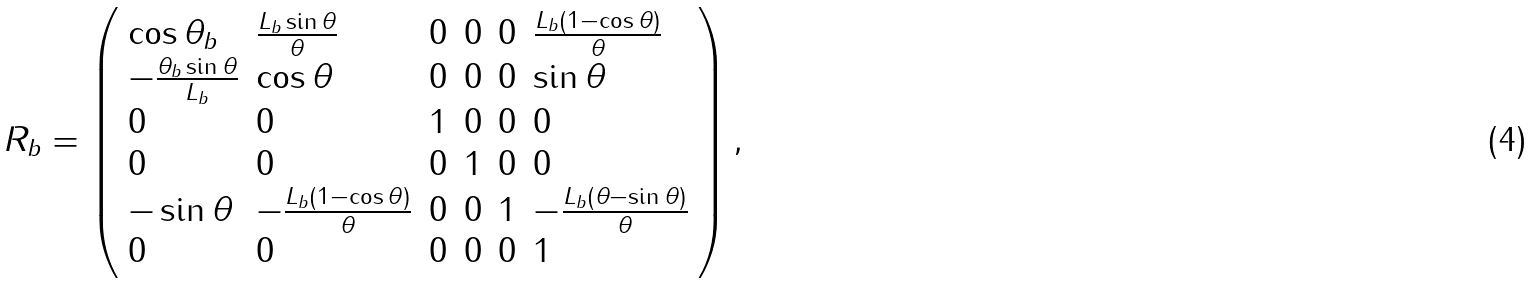Convert formula to latex. <formula><loc_0><loc_0><loc_500><loc_500>R _ { b } = \left ( \begin{array} { l l l l l l } \cos \theta _ { b } & \frac { L _ { b } \sin \theta } { \theta } & 0 & 0 & 0 & \frac { L _ { b } ( 1 - \cos \theta ) } { \theta } \\ - \frac { \theta _ { b } \sin \theta } { L _ { b } } & \cos \theta & 0 & 0 & 0 & \sin \theta \\ 0 & 0 & 1 & 0 & 0 & 0 \\ 0 & 0 & 0 & 1 & 0 & 0 \\ - \sin \theta & - \frac { L _ { b } ( 1 - \cos \theta ) } { \theta } & 0 & 0 & 1 & - \frac { L _ { b } ( \theta - \sin \theta ) } { \theta } \\ 0 & 0 & 0 & 0 & 0 & 1 \end{array} \right ) ,</formula> 